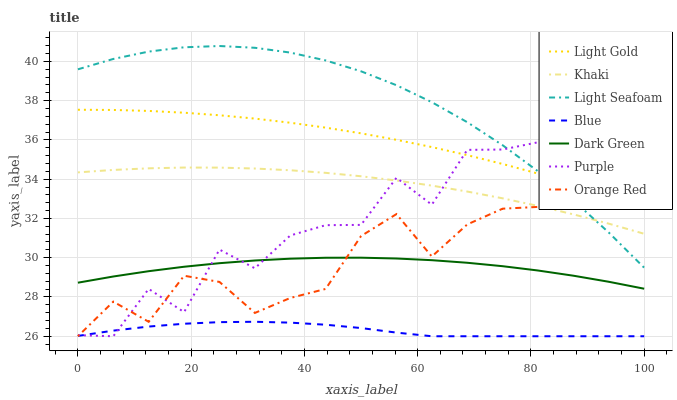Does Blue have the minimum area under the curve?
Answer yes or no. Yes. Does Light Seafoam have the maximum area under the curve?
Answer yes or no. Yes. Does Khaki have the minimum area under the curve?
Answer yes or no. No. Does Khaki have the maximum area under the curve?
Answer yes or no. No. Is Light Gold the smoothest?
Answer yes or no. Yes. Is Purple the roughest?
Answer yes or no. Yes. Is Khaki the smoothest?
Answer yes or no. No. Is Khaki the roughest?
Answer yes or no. No. Does Blue have the lowest value?
Answer yes or no. Yes. Does Khaki have the lowest value?
Answer yes or no. No. Does Light Seafoam have the highest value?
Answer yes or no. Yes. Does Khaki have the highest value?
Answer yes or no. No. Is Blue less than Dark Green?
Answer yes or no. Yes. Is Khaki greater than Dark Green?
Answer yes or no. Yes. Does Light Gold intersect Light Seafoam?
Answer yes or no. Yes. Is Light Gold less than Light Seafoam?
Answer yes or no. No. Is Light Gold greater than Light Seafoam?
Answer yes or no. No. Does Blue intersect Dark Green?
Answer yes or no. No. 